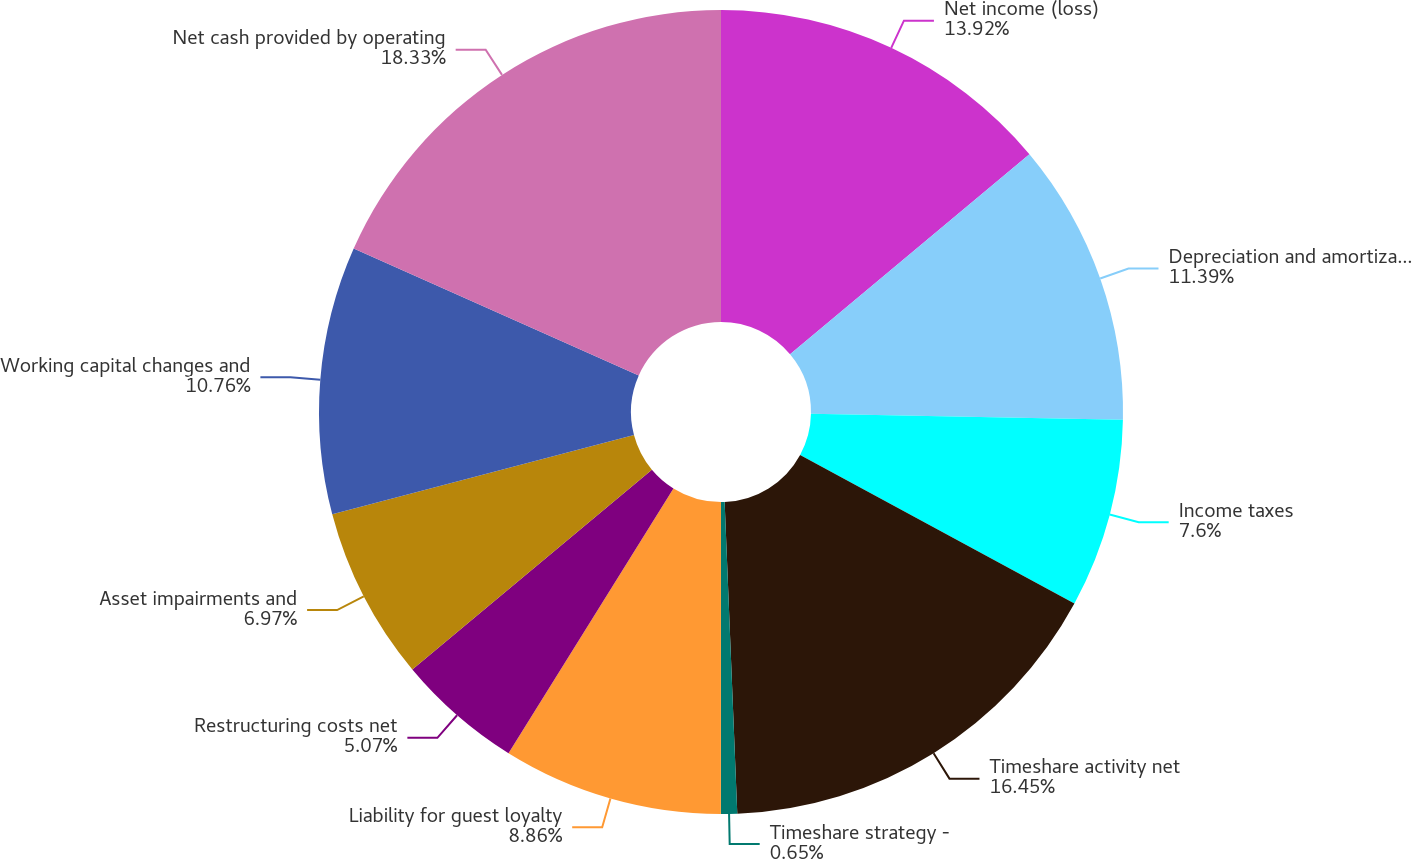Convert chart to OTSL. <chart><loc_0><loc_0><loc_500><loc_500><pie_chart><fcel>Net income (loss)<fcel>Depreciation and amortization<fcel>Income taxes<fcel>Timeshare activity net<fcel>Timeshare strategy -<fcel>Liability for guest loyalty<fcel>Restructuring costs net<fcel>Asset impairments and<fcel>Working capital changes and<fcel>Net cash provided by operating<nl><fcel>13.92%<fcel>11.39%<fcel>7.6%<fcel>16.45%<fcel>0.65%<fcel>8.86%<fcel>5.07%<fcel>6.97%<fcel>10.76%<fcel>18.34%<nl></chart> 